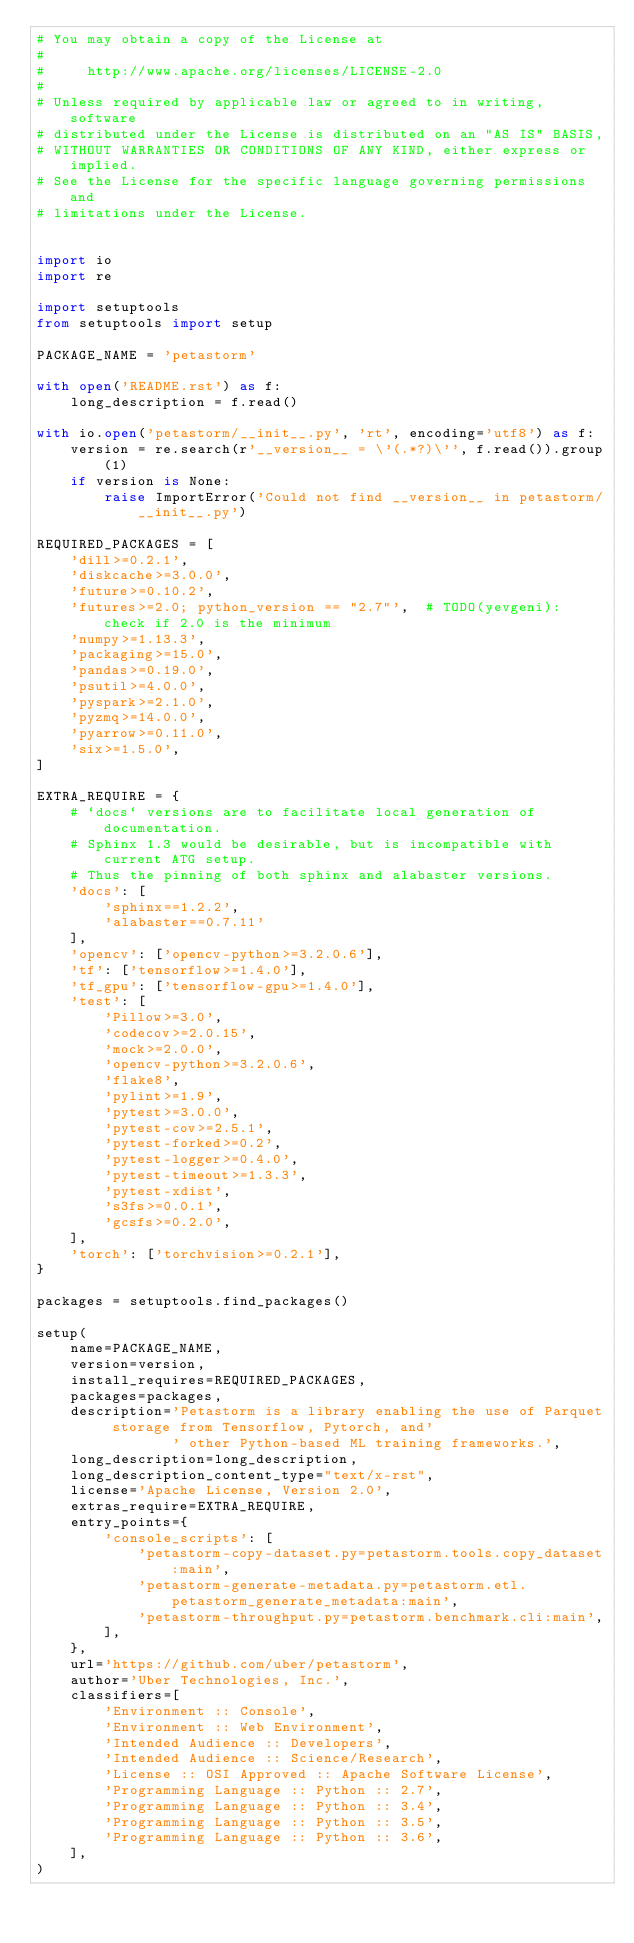<code> <loc_0><loc_0><loc_500><loc_500><_Python_># You may obtain a copy of the License at
#
#     http://www.apache.org/licenses/LICENSE-2.0
#
# Unless required by applicable law or agreed to in writing, software
# distributed under the License is distributed on an "AS IS" BASIS,
# WITHOUT WARRANTIES OR CONDITIONS OF ANY KIND, either express or implied.
# See the License for the specific language governing permissions and
# limitations under the License.


import io
import re

import setuptools
from setuptools import setup

PACKAGE_NAME = 'petastorm'

with open('README.rst') as f:
    long_description = f.read()

with io.open('petastorm/__init__.py', 'rt', encoding='utf8') as f:
    version = re.search(r'__version__ = \'(.*?)\'', f.read()).group(1)
    if version is None:
        raise ImportError('Could not find __version__ in petastorm/__init__.py')

REQUIRED_PACKAGES = [
    'dill>=0.2.1',
    'diskcache>=3.0.0',
    'future>=0.10.2',
    'futures>=2.0; python_version == "2.7"',  # TODO(yevgeni): check if 2.0 is the minimum
    'numpy>=1.13.3',
    'packaging>=15.0',
    'pandas>=0.19.0',
    'psutil>=4.0.0',
    'pyspark>=2.1.0',
    'pyzmq>=14.0.0',
    'pyarrow>=0.11.0',
    'six>=1.5.0',
]

EXTRA_REQUIRE = {
    # `docs` versions are to facilitate local generation of documentation.
    # Sphinx 1.3 would be desirable, but is incompatible with current ATG setup.
    # Thus the pinning of both sphinx and alabaster versions.
    'docs': [
        'sphinx==1.2.2',
        'alabaster==0.7.11'
    ],
    'opencv': ['opencv-python>=3.2.0.6'],
    'tf': ['tensorflow>=1.4.0'],
    'tf_gpu': ['tensorflow-gpu>=1.4.0'],
    'test': [
        'Pillow>=3.0',
        'codecov>=2.0.15',
        'mock>=2.0.0',
        'opencv-python>=3.2.0.6',
        'flake8',
        'pylint>=1.9',
        'pytest>=3.0.0',
        'pytest-cov>=2.5.1',
        'pytest-forked>=0.2',
        'pytest-logger>=0.4.0',
        'pytest-timeout>=1.3.3',
        'pytest-xdist',
        's3fs>=0.0.1',
        'gcsfs>=0.2.0',
    ],
    'torch': ['torchvision>=0.2.1'],
}

packages = setuptools.find_packages()

setup(
    name=PACKAGE_NAME,
    version=version,
    install_requires=REQUIRED_PACKAGES,
    packages=packages,
    description='Petastorm is a library enabling the use of Parquet storage from Tensorflow, Pytorch, and'
                ' other Python-based ML training frameworks.',
    long_description=long_description,
    long_description_content_type="text/x-rst",
    license='Apache License, Version 2.0',
    extras_require=EXTRA_REQUIRE,
    entry_points={
        'console_scripts': [
            'petastorm-copy-dataset.py=petastorm.tools.copy_dataset:main',
            'petastorm-generate-metadata.py=petastorm.etl.petastorm_generate_metadata:main',
            'petastorm-throughput.py=petastorm.benchmark.cli:main',
        ],
    },
    url='https://github.com/uber/petastorm',
    author='Uber Technologies, Inc.',
    classifiers=[
        'Environment :: Console',
        'Environment :: Web Environment',
        'Intended Audience :: Developers',
        'Intended Audience :: Science/Research',
        'License :: OSI Approved :: Apache Software License',
        'Programming Language :: Python :: 2.7',
        'Programming Language :: Python :: 3.4',
        'Programming Language :: Python :: 3.5',
        'Programming Language :: Python :: 3.6',
    ],
)
</code> 